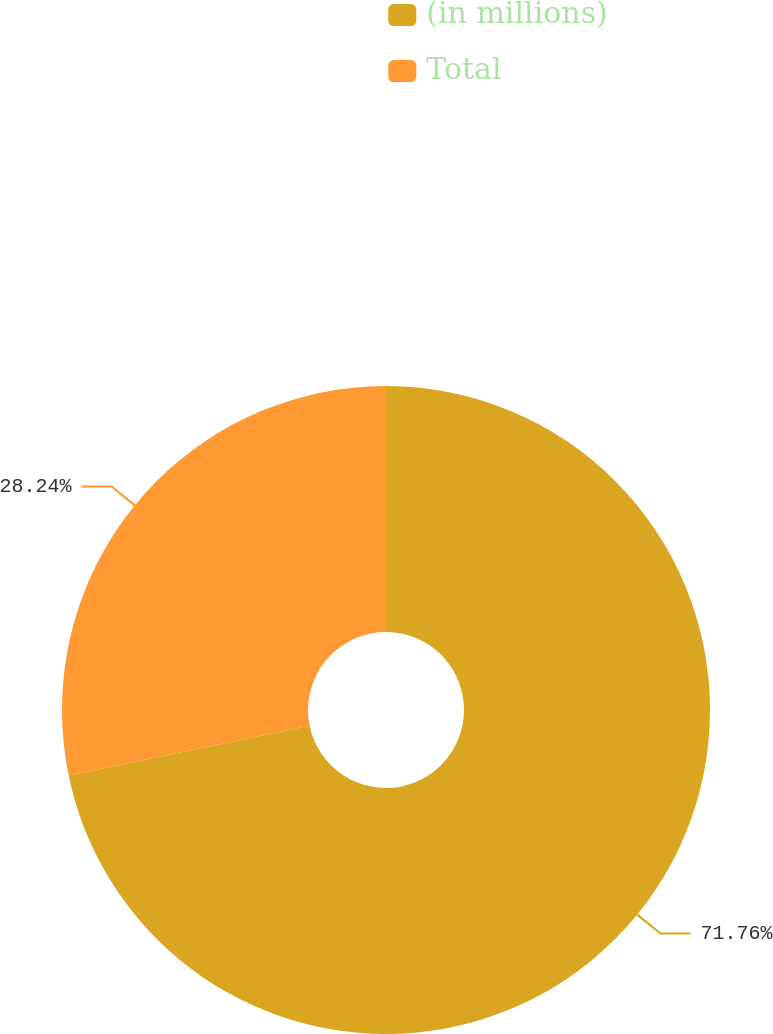Convert chart. <chart><loc_0><loc_0><loc_500><loc_500><pie_chart><fcel>(in millions)<fcel>Total<nl><fcel>71.76%<fcel>28.24%<nl></chart> 